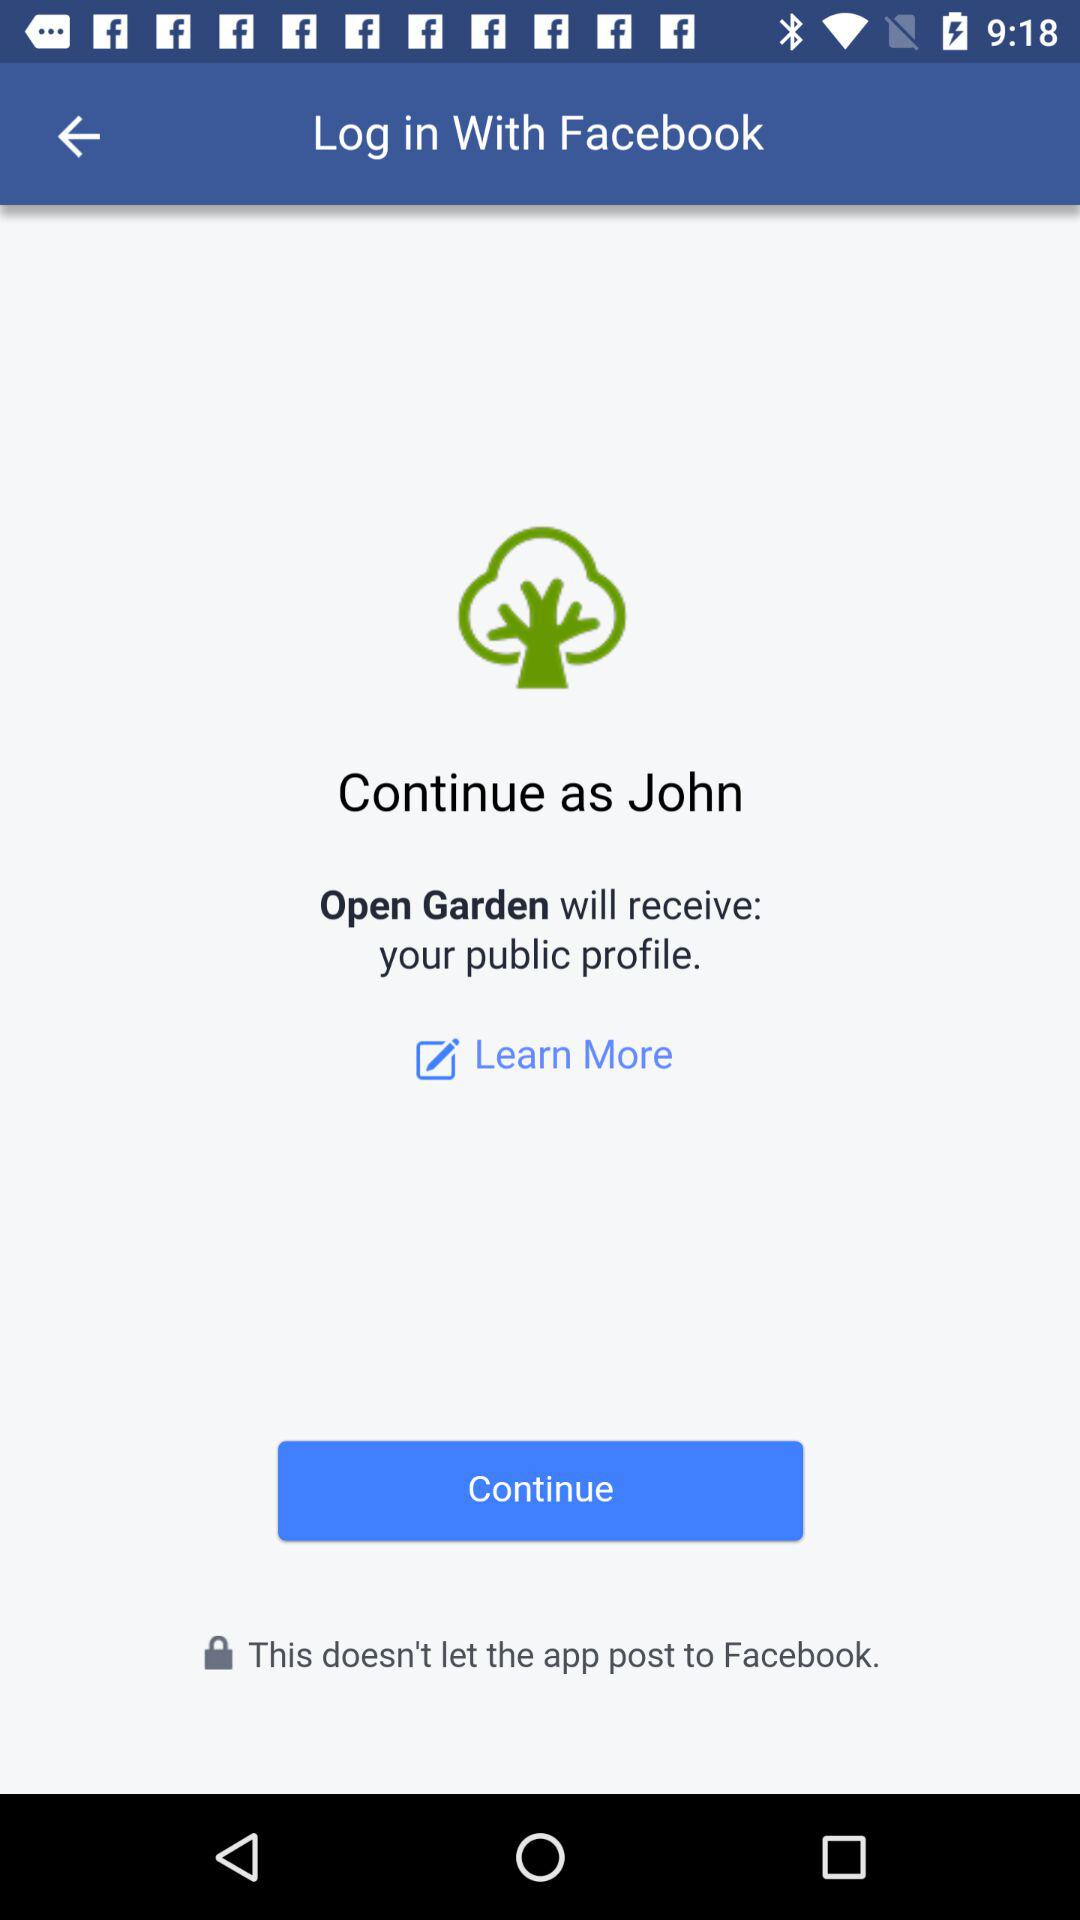What is the user name? The user name is John. 